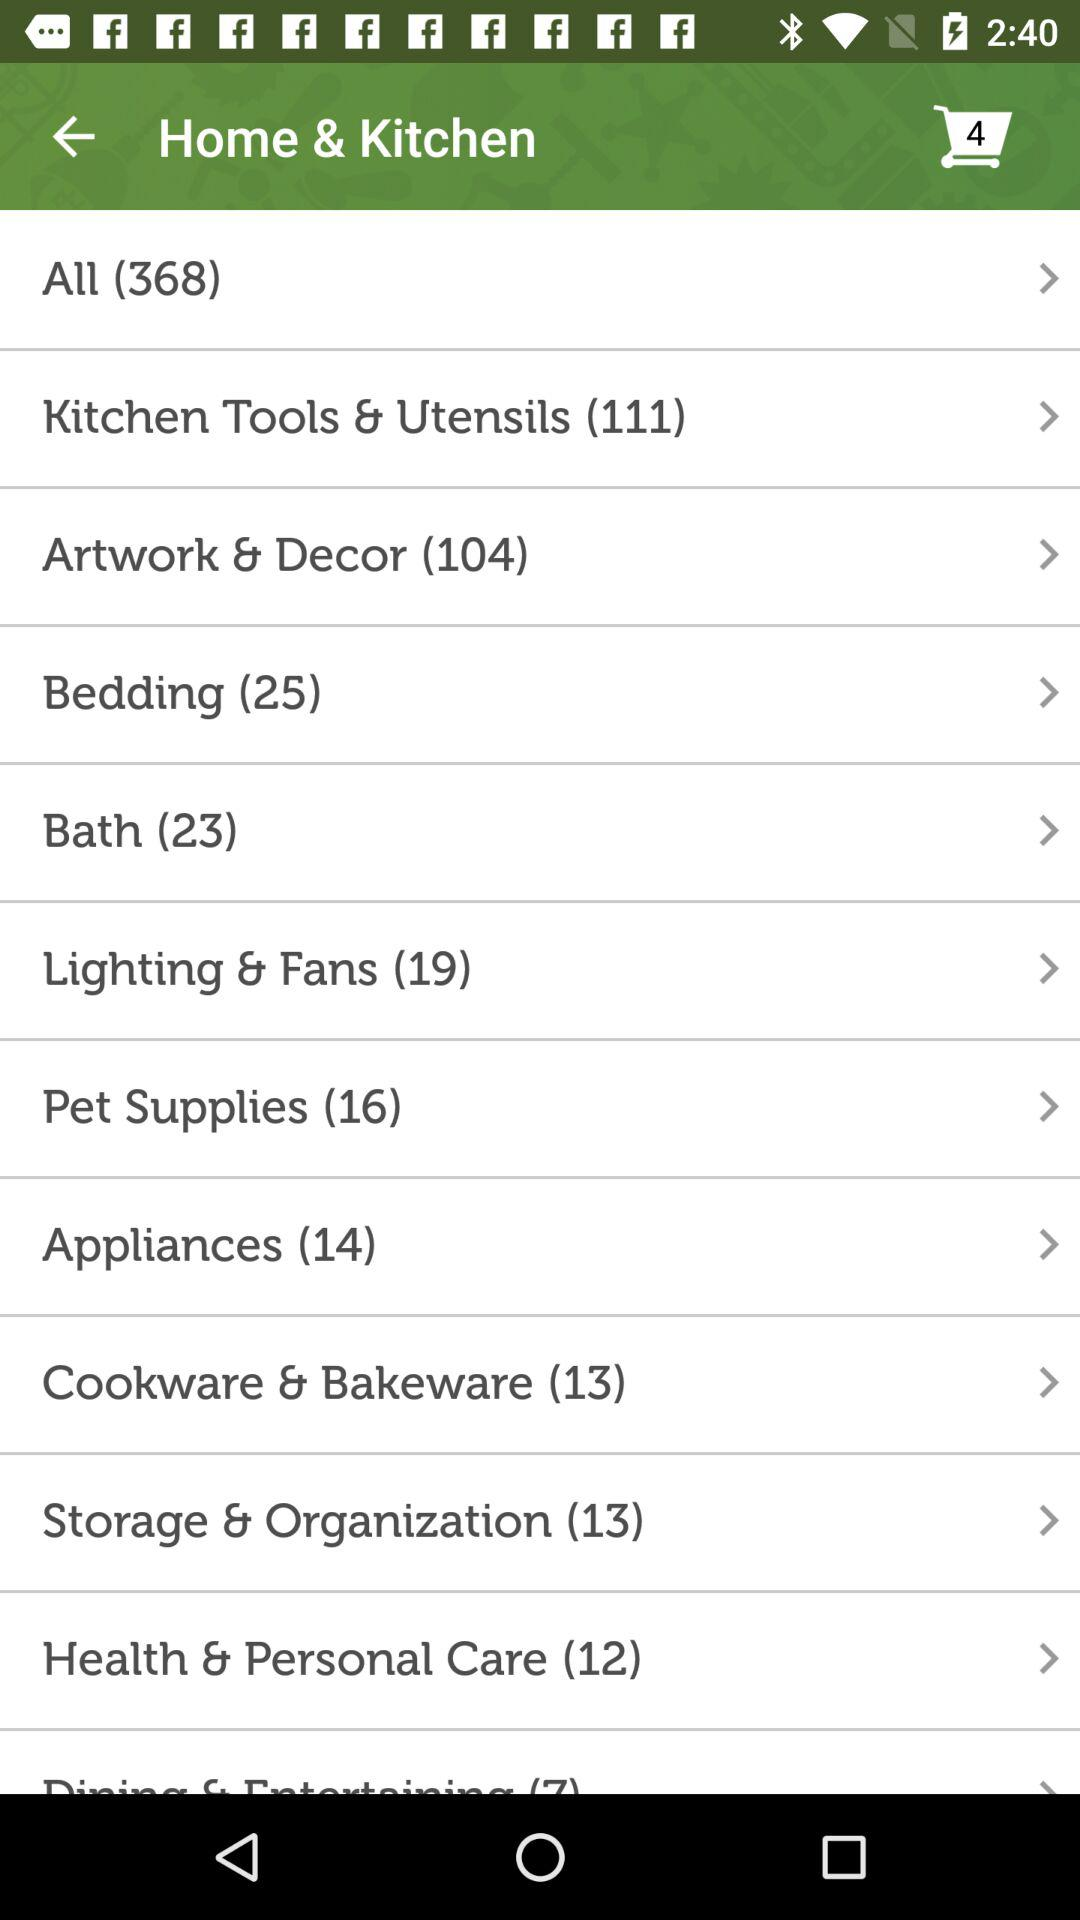What is the total number of products in the "Home & Kitchen" section? The total number of products is 368. 